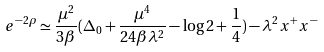<formula> <loc_0><loc_0><loc_500><loc_500>e ^ { - 2 \rho } \simeq \frac { \mu ^ { 2 } } { 3 \beta } ( \Delta _ { 0 } + \frac { \mu ^ { 4 } } { 2 4 \beta \lambda ^ { 2 } } - \log 2 + \frac { 1 } { 4 } ) - \lambda ^ { 2 } x ^ { + } x ^ { - }</formula> 